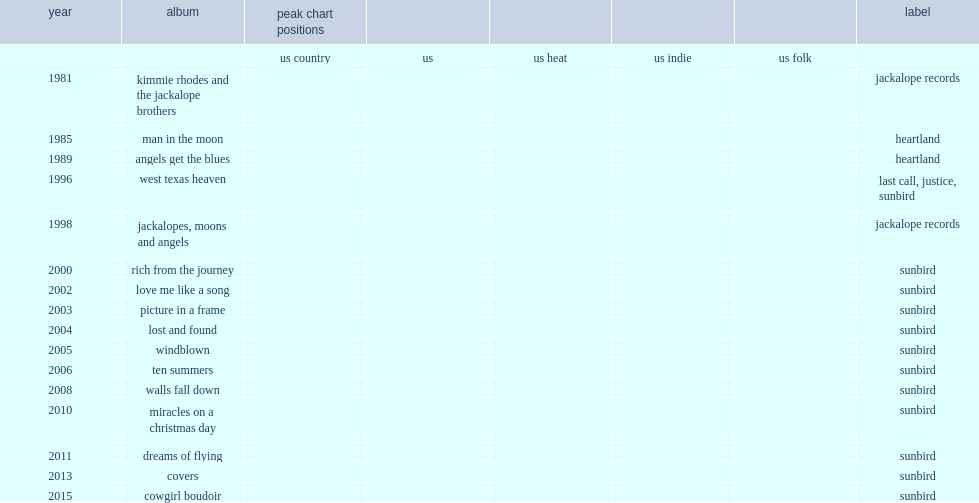Which label was kimmie rhodes' covers released through sunbird in 2013? Sunbird. 